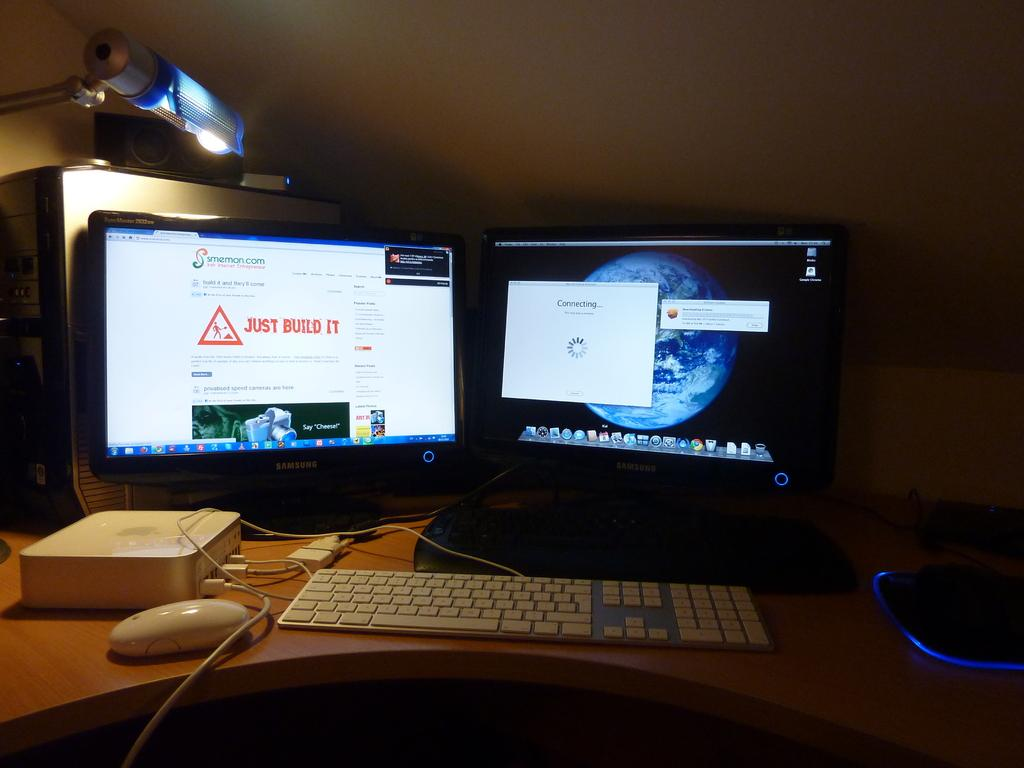What type of furniture is in the image? There is a table in the image. What is on the table? There is a mouse, a keyboard, a laptop, a monitor, and a CPU on the table. Are there any wires visible in the image? Yes, wires are present in the image. What type of light is visible in the image? There is a light in the image. What can be seen in the background of the image? A wall is visible in the image. What industry is the mouse working in, as depicted in the image? There is no indication of an industry or the mouse's occupation in the image; it simply shows a mouse on a table with various computer components. 